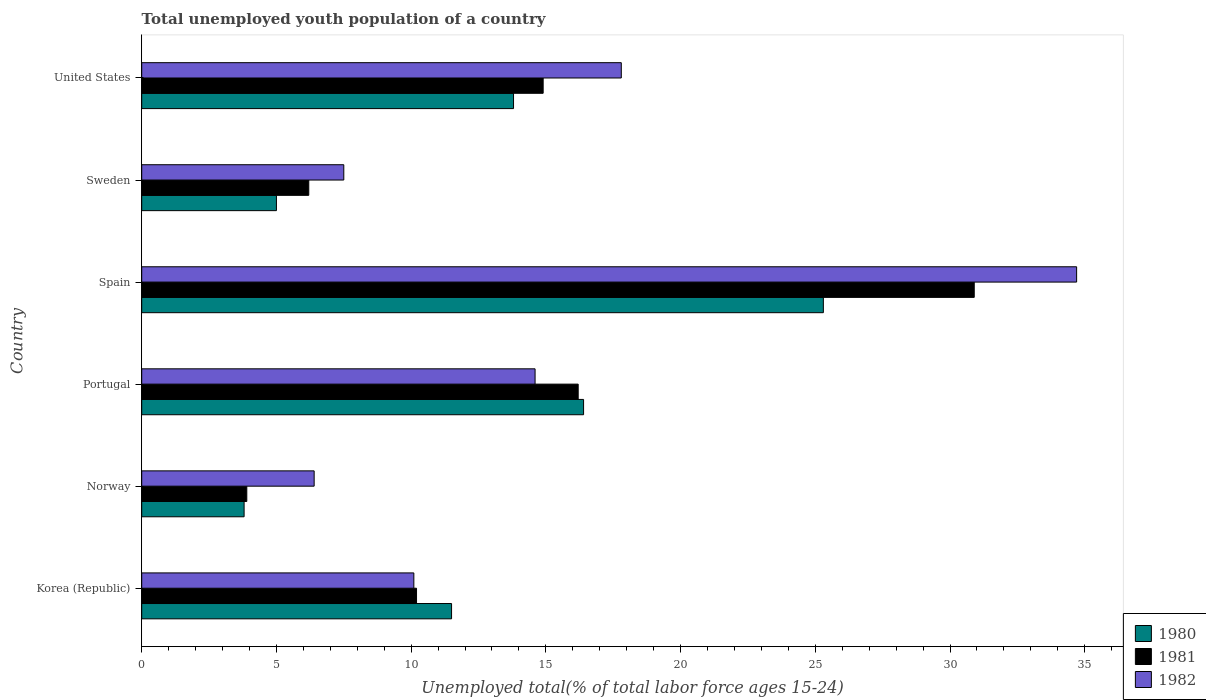Are the number of bars per tick equal to the number of legend labels?
Your answer should be compact. Yes. Are the number of bars on each tick of the Y-axis equal?
Your answer should be very brief. Yes. How many bars are there on the 1st tick from the top?
Provide a succinct answer. 3. How many bars are there on the 5th tick from the bottom?
Your answer should be compact. 3. What is the percentage of total unemployed youth population of a country in 1980 in Norway?
Offer a very short reply. 3.8. Across all countries, what is the maximum percentage of total unemployed youth population of a country in 1981?
Provide a succinct answer. 30.9. Across all countries, what is the minimum percentage of total unemployed youth population of a country in 1982?
Provide a short and direct response. 6.4. In which country was the percentage of total unemployed youth population of a country in 1982 maximum?
Offer a terse response. Spain. What is the total percentage of total unemployed youth population of a country in 1981 in the graph?
Your response must be concise. 82.3. What is the difference between the percentage of total unemployed youth population of a country in 1982 in Korea (Republic) and that in Spain?
Provide a short and direct response. -24.6. What is the difference between the percentage of total unemployed youth population of a country in 1980 in Spain and the percentage of total unemployed youth population of a country in 1981 in Portugal?
Provide a succinct answer. 9.1. What is the average percentage of total unemployed youth population of a country in 1980 per country?
Your answer should be compact. 12.63. What is the difference between the percentage of total unemployed youth population of a country in 1981 and percentage of total unemployed youth population of a country in 1982 in Korea (Republic)?
Offer a very short reply. 0.1. In how many countries, is the percentage of total unemployed youth population of a country in 1982 greater than 3 %?
Offer a very short reply. 6. What is the ratio of the percentage of total unemployed youth population of a country in 1982 in Portugal to that in United States?
Provide a succinct answer. 0.82. Is the percentage of total unemployed youth population of a country in 1980 in Sweden less than that in United States?
Ensure brevity in your answer.  Yes. What is the difference between the highest and the second highest percentage of total unemployed youth population of a country in 1980?
Your response must be concise. 8.9. What is the difference between the highest and the lowest percentage of total unemployed youth population of a country in 1982?
Your response must be concise. 28.3. In how many countries, is the percentage of total unemployed youth population of a country in 1980 greater than the average percentage of total unemployed youth population of a country in 1980 taken over all countries?
Offer a terse response. 3. What does the 1st bar from the bottom in Korea (Republic) represents?
Your answer should be very brief. 1980. Is it the case that in every country, the sum of the percentage of total unemployed youth population of a country in 1981 and percentage of total unemployed youth population of a country in 1982 is greater than the percentage of total unemployed youth population of a country in 1980?
Ensure brevity in your answer.  Yes. Are all the bars in the graph horizontal?
Provide a succinct answer. Yes. Are the values on the major ticks of X-axis written in scientific E-notation?
Keep it short and to the point. No. Does the graph contain any zero values?
Keep it short and to the point. No. Where does the legend appear in the graph?
Provide a short and direct response. Bottom right. How many legend labels are there?
Provide a short and direct response. 3. What is the title of the graph?
Your response must be concise. Total unemployed youth population of a country. Does "1998" appear as one of the legend labels in the graph?
Offer a terse response. No. What is the label or title of the X-axis?
Your answer should be very brief. Unemployed total(% of total labor force ages 15-24). What is the Unemployed total(% of total labor force ages 15-24) of 1980 in Korea (Republic)?
Offer a terse response. 11.5. What is the Unemployed total(% of total labor force ages 15-24) in 1981 in Korea (Republic)?
Offer a very short reply. 10.2. What is the Unemployed total(% of total labor force ages 15-24) in 1982 in Korea (Republic)?
Offer a terse response. 10.1. What is the Unemployed total(% of total labor force ages 15-24) of 1980 in Norway?
Ensure brevity in your answer.  3.8. What is the Unemployed total(% of total labor force ages 15-24) of 1981 in Norway?
Provide a short and direct response. 3.9. What is the Unemployed total(% of total labor force ages 15-24) of 1982 in Norway?
Your answer should be very brief. 6.4. What is the Unemployed total(% of total labor force ages 15-24) in 1980 in Portugal?
Keep it short and to the point. 16.4. What is the Unemployed total(% of total labor force ages 15-24) of 1981 in Portugal?
Give a very brief answer. 16.2. What is the Unemployed total(% of total labor force ages 15-24) of 1982 in Portugal?
Make the answer very short. 14.6. What is the Unemployed total(% of total labor force ages 15-24) of 1980 in Spain?
Offer a very short reply. 25.3. What is the Unemployed total(% of total labor force ages 15-24) in 1981 in Spain?
Provide a short and direct response. 30.9. What is the Unemployed total(% of total labor force ages 15-24) of 1982 in Spain?
Offer a very short reply. 34.7. What is the Unemployed total(% of total labor force ages 15-24) in 1981 in Sweden?
Your answer should be very brief. 6.2. What is the Unemployed total(% of total labor force ages 15-24) of 1982 in Sweden?
Give a very brief answer. 7.5. What is the Unemployed total(% of total labor force ages 15-24) in 1980 in United States?
Your answer should be compact. 13.8. What is the Unemployed total(% of total labor force ages 15-24) in 1981 in United States?
Ensure brevity in your answer.  14.9. What is the Unemployed total(% of total labor force ages 15-24) in 1982 in United States?
Provide a succinct answer. 17.8. Across all countries, what is the maximum Unemployed total(% of total labor force ages 15-24) in 1980?
Make the answer very short. 25.3. Across all countries, what is the maximum Unemployed total(% of total labor force ages 15-24) in 1981?
Offer a terse response. 30.9. Across all countries, what is the maximum Unemployed total(% of total labor force ages 15-24) of 1982?
Offer a terse response. 34.7. Across all countries, what is the minimum Unemployed total(% of total labor force ages 15-24) of 1980?
Offer a very short reply. 3.8. Across all countries, what is the minimum Unemployed total(% of total labor force ages 15-24) of 1981?
Give a very brief answer. 3.9. Across all countries, what is the minimum Unemployed total(% of total labor force ages 15-24) in 1982?
Offer a very short reply. 6.4. What is the total Unemployed total(% of total labor force ages 15-24) of 1980 in the graph?
Offer a very short reply. 75.8. What is the total Unemployed total(% of total labor force ages 15-24) of 1981 in the graph?
Make the answer very short. 82.3. What is the total Unemployed total(% of total labor force ages 15-24) in 1982 in the graph?
Offer a very short reply. 91.1. What is the difference between the Unemployed total(% of total labor force ages 15-24) of 1980 in Korea (Republic) and that in Norway?
Provide a succinct answer. 7.7. What is the difference between the Unemployed total(% of total labor force ages 15-24) in 1981 in Korea (Republic) and that in Norway?
Keep it short and to the point. 6.3. What is the difference between the Unemployed total(% of total labor force ages 15-24) in 1982 in Korea (Republic) and that in Norway?
Your response must be concise. 3.7. What is the difference between the Unemployed total(% of total labor force ages 15-24) of 1980 in Korea (Republic) and that in Portugal?
Ensure brevity in your answer.  -4.9. What is the difference between the Unemployed total(% of total labor force ages 15-24) of 1981 in Korea (Republic) and that in Spain?
Offer a very short reply. -20.7. What is the difference between the Unemployed total(% of total labor force ages 15-24) in 1982 in Korea (Republic) and that in Spain?
Your answer should be very brief. -24.6. What is the difference between the Unemployed total(% of total labor force ages 15-24) of 1982 in Korea (Republic) and that in Sweden?
Your response must be concise. 2.6. What is the difference between the Unemployed total(% of total labor force ages 15-24) of 1980 in Norway and that in Portugal?
Provide a succinct answer. -12.6. What is the difference between the Unemployed total(% of total labor force ages 15-24) of 1981 in Norway and that in Portugal?
Provide a short and direct response. -12.3. What is the difference between the Unemployed total(% of total labor force ages 15-24) in 1980 in Norway and that in Spain?
Your answer should be very brief. -21.5. What is the difference between the Unemployed total(% of total labor force ages 15-24) in 1982 in Norway and that in Spain?
Provide a succinct answer. -28.3. What is the difference between the Unemployed total(% of total labor force ages 15-24) in 1982 in Norway and that in Sweden?
Ensure brevity in your answer.  -1.1. What is the difference between the Unemployed total(% of total labor force ages 15-24) in 1981 in Norway and that in United States?
Ensure brevity in your answer.  -11. What is the difference between the Unemployed total(% of total labor force ages 15-24) in 1980 in Portugal and that in Spain?
Offer a very short reply. -8.9. What is the difference between the Unemployed total(% of total labor force ages 15-24) in 1981 in Portugal and that in Spain?
Your answer should be compact. -14.7. What is the difference between the Unemployed total(% of total labor force ages 15-24) of 1982 in Portugal and that in Spain?
Give a very brief answer. -20.1. What is the difference between the Unemployed total(% of total labor force ages 15-24) in 1980 in Portugal and that in Sweden?
Your response must be concise. 11.4. What is the difference between the Unemployed total(% of total labor force ages 15-24) in 1981 in Portugal and that in Sweden?
Your answer should be very brief. 10. What is the difference between the Unemployed total(% of total labor force ages 15-24) in 1980 in Portugal and that in United States?
Give a very brief answer. 2.6. What is the difference between the Unemployed total(% of total labor force ages 15-24) of 1981 in Portugal and that in United States?
Make the answer very short. 1.3. What is the difference between the Unemployed total(% of total labor force ages 15-24) in 1980 in Spain and that in Sweden?
Your answer should be compact. 20.3. What is the difference between the Unemployed total(% of total labor force ages 15-24) in 1981 in Spain and that in Sweden?
Provide a short and direct response. 24.7. What is the difference between the Unemployed total(% of total labor force ages 15-24) of 1982 in Spain and that in Sweden?
Provide a short and direct response. 27.2. What is the difference between the Unemployed total(% of total labor force ages 15-24) of 1980 in Spain and that in United States?
Make the answer very short. 11.5. What is the difference between the Unemployed total(% of total labor force ages 15-24) in 1982 in Spain and that in United States?
Provide a succinct answer. 16.9. What is the difference between the Unemployed total(% of total labor force ages 15-24) of 1982 in Sweden and that in United States?
Provide a short and direct response. -10.3. What is the difference between the Unemployed total(% of total labor force ages 15-24) of 1980 in Korea (Republic) and the Unemployed total(% of total labor force ages 15-24) of 1981 in Spain?
Give a very brief answer. -19.4. What is the difference between the Unemployed total(% of total labor force ages 15-24) in 1980 in Korea (Republic) and the Unemployed total(% of total labor force ages 15-24) in 1982 in Spain?
Offer a very short reply. -23.2. What is the difference between the Unemployed total(% of total labor force ages 15-24) of 1981 in Korea (Republic) and the Unemployed total(% of total labor force ages 15-24) of 1982 in Spain?
Your answer should be very brief. -24.5. What is the difference between the Unemployed total(% of total labor force ages 15-24) of 1980 in Korea (Republic) and the Unemployed total(% of total labor force ages 15-24) of 1981 in Sweden?
Give a very brief answer. 5.3. What is the difference between the Unemployed total(% of total labor force ages 15-24) of 1981 in Korea (Republic) and the Unemployed total(% of total labor force ages 15-24) of 1982 in Sweden?
Your response must be concise. 2.7. What is the difference between the Unemployed total(% of total labor force ages 15-24) of 1980 in Korea (Republic) and the Unemployed total(% of total labor force ages 15-24) of 1981 in United States?
Your answer should be compact. -3.4. What is the difference between the Unemployed total(% of total labor force ages 15-24) of 1980 in Korea (Republic) and the Unemployed total(% of total labor force ages 15-24) of 1982 in United States?
Your answer should be very brief. -6.3. What is the difference between the Unemployed total(% of total labor force ages 15-24) in 1981 in Korea (Republic) and the Unemployed total(% of total labor force ages 15-24) in 1982 in United States?
Your response must be concise. -7.6. What is the difference between the Unemployed total(% of total labor force ages 15-24) of 1980 in Norway and the Unemployed total(% of total labor force ages 15-24) of 1981 in Spain?
Your answer should be compact. -27.1. What is the difference between the Unemployed total(% of total labor force ages 15-24) in 1980 in Norway and the Unemployed total(% of total labor force ages 15-24) in 1982 in Spain?
Give a very brief answer. -30.9. What is the difference between the Unemployed total(% of total labor force ages 15-24) of 1981 in Norway and the Unemployed total(% of total labor force ages 15-24) of 1982 in Spain?
Provide a short and direct response. -30.8. What is the difference between the Unemployed total(% of total labor force ages 15-24) in 1980 in Norway and the Unemployed total(% of total labor force ages 15-24) in 1981 in Sweden?
Your answer should be compact. -2.4. What is the difference between the Unemployed total(% of total labor force ages 15-24) in 1981 in Norway and the Unemployed total(% of total labor force ages 15-24) in 1982 in Sweden?
Offer a terse response. -3.6. What is the difference between the Unemployed total(% of total labor force ages 15-24) in 1980 in Norway and the Unemployed total(% of total labor force ages 15-24) in 1981 in United States?
Your answer should be very brief. -11.1. What is the difference between the Unemployed total(% of total labor force ages 15-24) of 1980 in Portugal and the Unemployed total(% of total labor force ages 15-24) of 1982 in Spain?
Offer a very short reply. -18.3. What is the difference between the Unemployed total(% of total labor force ages 15-24) of 1981 in Portugal and the Unemployed total(% of total labor force ages 15-24) of 1982 in Spain?
Provide a succinct answer. -18.5. What is the difference between the Unemployed total(% of total labor force ages 15-24) in 1980 in Portugal and the Unemployed total(% of total labor force ages 15-24) in 1981 in Sweden?
Ensure brevity in your answer.  10.2. What is the difference between the Unemployed total(% of total labor force ages 15-24) in 1980 in Spain and the Unemployed total(% of total labor force ages 15-24) in 1981 in Sweden?
Provide a short and direct response. 19.1. What is the difference between the Unemployed total(% of total labor force ages 15-24) of 1981 in Spain and the Unemployed total(% of total labor force ages 15-24) of 1982 in Sweden?
Your answer should be very brief. 23.4. What is the difference between the Unemployed total(% of total labor force ages 15-24) in 1980 in Spain and the Unemployed total(% of total labor force ages 15-24) in 1981 in United States?
Offer a terse response. 10.4. What is the difference between the Unemployed total(% of total labor force ages 15-24) in 1980 in Spain and the Unemployed total(% of total labor force ages 15-24) in 1982 in United States?
Give a very brief answer. 7.5. What is the difference between the Unemployed total(% of total labor force ages 15-24) in 1980 in Sweden and the Unemployed total(% of total labor force ages 15-24) in 1981 in United States?
Keep it short and to the point. -9.9. What is the difference between the Unemployed total(% of total labor force ages 15-24) in 1980 in Sweden and the Unemployed total(% of total labor force ages 15-24) in 1982 in United States?
Give a very brief answer. -12.8. What is the average Unemployed total(% of total labor force ages 15-24) in 1980 per country?
Make the answer very short. 12.63. What is the average Unemployed total(% of total labor force ages 15-24) in 1981 per country?
Provide a succinct answer. 13.72. What is the average Unemployed total(% of total labor force ages 15-24) of 1982 per country?
Make the answer very short. 15.18. What is the difference between the Unemployed total(% of total labor force ages 15-24) in 1980 and Unemployed total(% of total labor force ages 15-24) in 1982 in Norway?
Keep it short and to the point. -2.6. What is the difference between the Unemployed total(% of total labor force ages 15-24) in 1981 and Unemployed total(% of total labor force ages 15-24) in 1982 in Norway?
Make the answer very short. -2.5. What is the difference between the Unemployed total(% of total labor force ages 15-24) of 1980 and Unemployed total(% of total labor force ages 15-24) of 1981 in Portugal?
Give a very brief answer. 0.2. What is the difference between the Unemployed total(% of total labor force ages 15-24) of 1981 and Unemployed total(% of total labor force ages 15-24) of 1982 in Portugal?
Offer a terse response. 1.6. What is the difference between the Unemployed total(% of total labor force ages 15-24) in 1980 and Unemployed total(% of total labor force ages 15-24) in 1982 in Spain?
Ensure brevity in your answer.  -9.4. What is the difference between the Unemployed total(% of total labor force ages 15-24) of 1981 and Unemployed total(% of total labor force ages 15-24) of 1982 in Spain?
Provide a short and direct response. -3.8. What is the difference between the Unemployed total(% of total labor force ages 15-24) of 1980 and Unemployed total(% of total labor force ages 15-24) of 1982 in Sweden?
Your response must be concise. -2.5. What is the difference between the Unemployed total(% of total labor force ages 15-24) of 1980 and Unemployed total(% of total labor force ages 15-24) of 1981 in United States?
Make the answer very short. -1.1. What is the ratio of the Unemployed total(% of total labor force ages 15-24) in 1980 in Korea (Republic) to that in Norway?
Keep it short and to the point. 3.03. What is the ratio of the Unemployed total(% of total labor force ages 15-24) in 1981 in Korea (Republic) to that in Norway?
Provide a succinct answer. 2.62. What is the ratio of the Unemployed total(% of total labor force ages 15-24) in 1982 in Korea (Republic) to that in Norway?
Offer a very short reply. 1.58. What is the ratio of the Unemployed total(% of total labor force ages 15-24) of 1980 in Korea (Republic) to that in Portugal?
Ensure brevity in your answer.  0.7. What is the ratio of the Unemployed total(% of total labor force ages 15-24) of 1981 in Korea (Republic) to that in Portugal?
Provide a short and direct response. 0.63. What is the ratio of the Unemployed total(% of total labor force ages 15-24) in 1982 in Korea (Republic) to that in Portugal?
Offer a terse response. 0.69. What is the ratio of the Unemployed total(% of total labor force ages 15-24) of 1980 in Korea (Republic) to that in Spain?
Offer a very short reply. 0.45. What is the ratio of the Unemployed total(% of total labor force ages 15-24) in 1981 in Korea (Republic) to that in Spain?
Offer a terse response. 0.33. What is the ratio of the Unemployed total(% of total labor force ages 15-24) in 1982 in Korea (Republic) to that in Spain?
Keep it short and to the point. 0.29. What is the ratio of the Unemployed total(% of total labor force ages 15-24) of 1980 in Korea (Republic) to that in Sweden?
Provide a succinct answer. 2.3. What is the ratio of the Unemployed total(% of total labor force ages 15-24) in 1981 in Korea (Republic) to that in Sweden?
Offer a very short reply. 1.65. What is the ratio of the Unemployed total(% of total labor force ages 15-24) in 1982 in Korea (Republic) to that in Sweden?
Offer a terse response. 1.35. What is the ratio of the Unemployed total(% of total labor force ages 15-24) of 1981 in Korea (Republic) to that in United States?
Offer a very short reply. 0.68. What is the ratio of the Unemployed total(% of total labor force ages 15-24) in 1982 in Korea (Republic) to that in United States?
Offer a terse response. 0.57. What is the ratio of the Unemployed total(% of total labor force ages 15-24) in 1980 in Norway to that in Portugal?
Ensure brevity in your answer.  0.23. What is the ratio of the Unemployed total(% of total labor force ages 15-24) in 1981 in Norway to that in Portugal?
Your answer should be very brief. 0.24. What is the ratio of the Unemployed total(% of total labor force ages 15-24) of 1982 in Norway to that in Portugal?
Give a very brief answer. 0.44. What is the ratio of the Unemployed total(% of total labor force ages 15-24) in 1980 in Norway to that in Spain?
Keep it short and to the point. 0.15. What is the ratio of the Unemployed total(% of total labor force ages 15-24) in 1981 in Norway to that in Spain?
Make the answer very short. 0.13. What is the ratio of the Unemployed total(% of total labor force ages 15-24) in 1982 in Norway to that in Spain?
Keep it short and to the point. 0.18. What is the ratio of the Unemployed total(% of total labor force ages 15-24) in 1980 in Norway to that in Sweden?
Give a very brief answer. 0.76. What is the ratio of the Unemployed total(% of total labor force ages 15-24) of 1981 in Norway to that in Sweden?
Your answer should be compact. 0.63. What is the ratio of the Unemployed total(% of total labor force ages 15-24) in 1982 in Norway to that in Sweden?
Offer a terse response. 0.85. What is the ratio of the Unemployed total(% of total labor force ages 15-24) of 1980 in Norway to that in United States?
Keep it short and to the point. 0.28. What is the ratio of the Unemployed total(% of total labor force ages 15-24) of 1981 in Norway to that in United States?
Keep it short and to the point. 0.26. What is the ratio of the Unemployed total(% of total labor force ages 15-24) in 1982 in Norway to that in United States?
Your answer should be compact. 0.36. What is the ratio of the Unemployed total(% of total labor force ages 15-24) of 1980 in Portugal to that in Spain?
Provide a short and direct response. 0.65. What is the ratio of the Unemployed total(% of total labor force ages 15-24) in 1981 in Portugal to that in Spain?
Offer a terse response. 0.52. What is the ratio of the Unemployed total(% of total labor force ages 15-24) of 1982 in Portugal to that in Spain?
Keep it short and to the point. 0.42. What is the ratio of the Unemployed total(% of total labor force ages 15-24) in 1980 in Portugal to that in Sweden?
Your answer should be very brief. 3.28. What is the ratio of the Unemployed total(% of total labor force ages 15-24) in 1981 in Portugal to that in Sweden?
Ensure brevity in your answer.  2.61. What is the ratio of the Unemployed total(% of total labor force ages 15-24) of 1982 in Portugal to that in Sweden?
Offer a very short reply. 1.95. What is the ratio of the Unemployed total(% of total labor force ages 15-24) of 1980 in Portugal to that in United States?
Keep it short and to the point. 1.19. What is the ratio of the Unemployed total(% of total labor force ages 15-24) in 1981 in Portugal to that in United States?
Provide a succinct answer. 1.09. What is the ratio of the Unemployed total(% of total labor force ages 15-24) in 1982 in Portugal to that in United States?
Provide a short and direct response. 0.82. What is the ratio of the Unemployed total(% of total labor force ages 15-24) of 1980 in Spain to that in Sweden?
Make the answer very short. 5.06. What is the ratio of the Unemployed total(% of total labor force ages 15-24) of 1981 in Spain to that in Sweden?
Ensure brevity in your answer.  4.98. What is the ratio of the Unemployed total(% of total labor force ages 15-24) of 1982 in Spain to that in Sweden?
Ensure brevity in your answer.  4.63. What is the ratio of the Unemployed total(% of total labor force ages 15-24) of 1980 in Spain to that in United States?
Keep it short and to the point. 1.83. What is the ratio of the Unemployed total(% of total labor force ages 15-24) of 1981 in Spain to that in United States?
Keep it short and to the point. 2.07. What is the ratio of the Unemployed total(% of total labor force ages 15-24) of 1982 in Spain to that in United States?
Your answer should be compact. 1.95. What is the ratio of the Unemployed total(% of total labor force ages 15-24) of 1980 in Sweden to that in United States?
Give a very brief answer. 0.36. What is the ratio of the Unemployed total(% of total labor force ages 15-24) in 1981 in Sweden to that in United States?
Provide a short and direct response. 0.42. What is the ratio of the Unemployed total(% of total labor force ages 15-24) in 1982 in Sweden to that in United States?
Provide a short and direct response. 0.42. What is the difference between the highest and the second highest Unemployed total(% of total labor force ages 15-24) in 1981?
Give a very brief answer. 14.7. What is the difference between the highest and the second highest Unemployed total(% of total labor force ages 15-24) of 1982?
Ensure brevity in your answer.  16.9. What is the difference between the highest and the lowest Unemployed total(% of total labor force ages 15-24) in 1980?
Give a very brief answer. 21.5. What is the difference between the highest and the lowest Unemployed total(% of total labor force ages 15-24) in 1981?
Your answer should be compact. 27. What is the difference between the highest and the lowest Unemployed total(% of total labor force ages 15-24) of 1982?
Your answer should be compact. 28.3. 